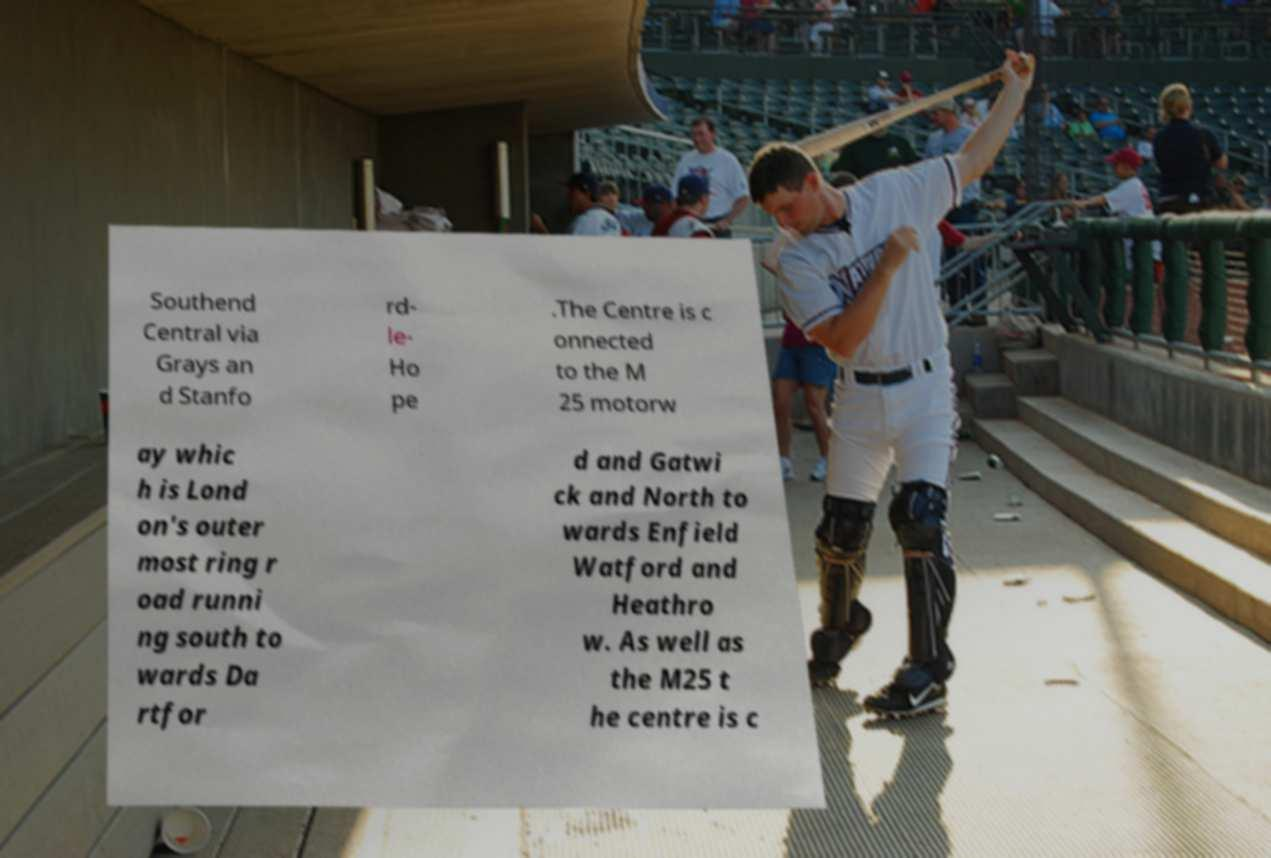For documentation purposes, I need the text within this image transcribed. Could you provide that? Southend Central via Grays an d Stanfo rd- le- Ho pe .The Centre is c onnected to the M 25 motorw ay whic h is Lond on's outer most ring r oad runni ng south to wards Da rtfor d and Gatwi ck and North to wards Enfield Watford and Heathro w. As well as the M25 t he centre is c 